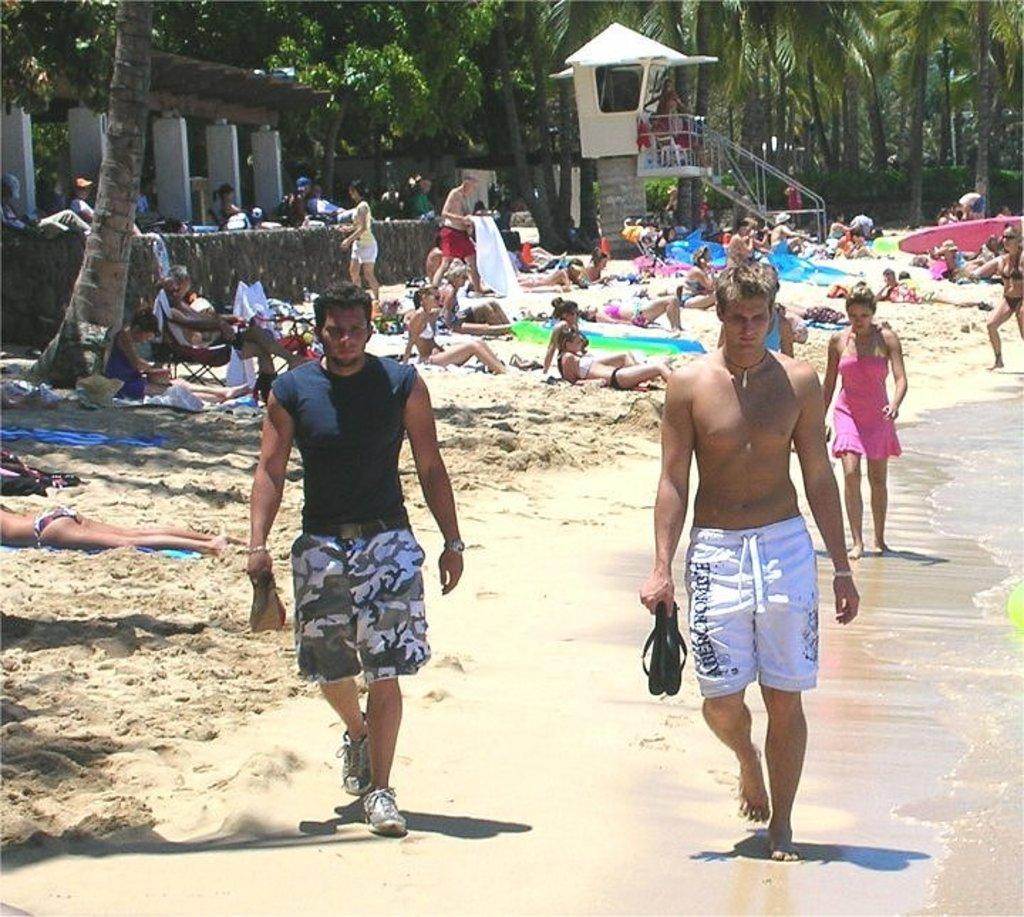What type of location is depicted in the image? There is a beach in the image. What are the people near the beach doing? Some people are resting on the sand, while others are walking on the seashore. What can be seen behind the sand in the image? There are plenty of trees behind the sand. What type of whistle can be heard coming from the boy in the image? There is no boy present in the image, and therefore no whistle can be heard. 